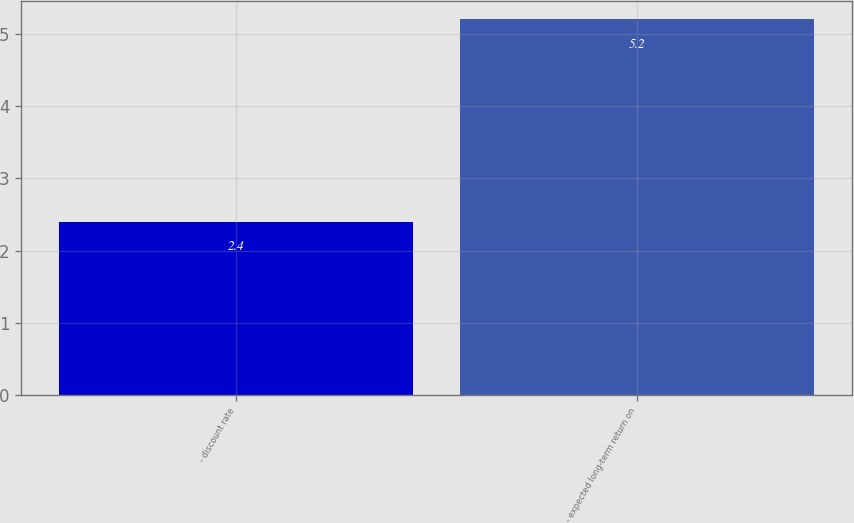Convert chart to OTSL. <chart><loc_0><loc_0><loc_500><loc_500><bar_chart><fcel>- discount rate<fcel>- expected long-term return on<nl><fcel>2.4<fcel>5.2<nl></chart> 